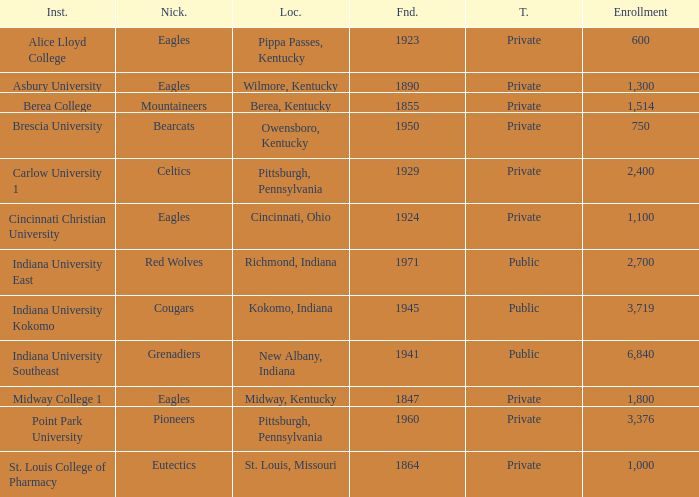Which college's enrollment is less than 1,000? Alice Lloyd College, Brescia University. Would you mind parsing the complete table? {'header': ['Inst.', 'Nick.', 'Loc.', 'Fnd.', 'T.', 'Enrollment'], 'rows': [['Alice Lloyd College', 'Eagles', 'Pippa Passes, Kentucky', '1923', 'Private', '600'], ['Asbury University', 'Eagles', 'Wilmore, Kentucky', '1890', 'Private', '1,300'], ['Berea College', 'Mountaineers', 'Berea, Kentucky', '1855', 'Private', '1,514'], ['Brescia University', 'Bearcats', 'Owensboro, Kentucky', '1950', 'Private', '750'], ['Carlow University 1', 'Celtics', 'Pittsburgh, Pennsylvania', '1929', 'Private', '2,400'], ['Cincinnati Christian University', 'Eagles', 'Cincinnati, Ohio', '1924', 'Private', '1,100'], ['Indiana University East', 'Red Wolves', 'Richmond, Indiana', '1971', 'Public', '2,700'], ['Indiana University Kokomo', 'Cougars', 'Kokomo, Indiana', '1945', 'Public', '3,719'], ['Indiana University Southeast', 'Grenadiers', 'New Albany, Indiana', '1941', 'Public', '6,840'], ['Midway College 1', 'Eagles', 'Midway, Kentucky', '1847', 'Private', '1,800'], ['Point Park University', 'Pioneers', 'Pittsburgh, Pennsylvania', '1960', 'Private', '3,376'], ['St. Louis College of Pharmacy', 'Eutectics', 'St. Louis, Missouri', '1864', 'Private', '1,000']]} 